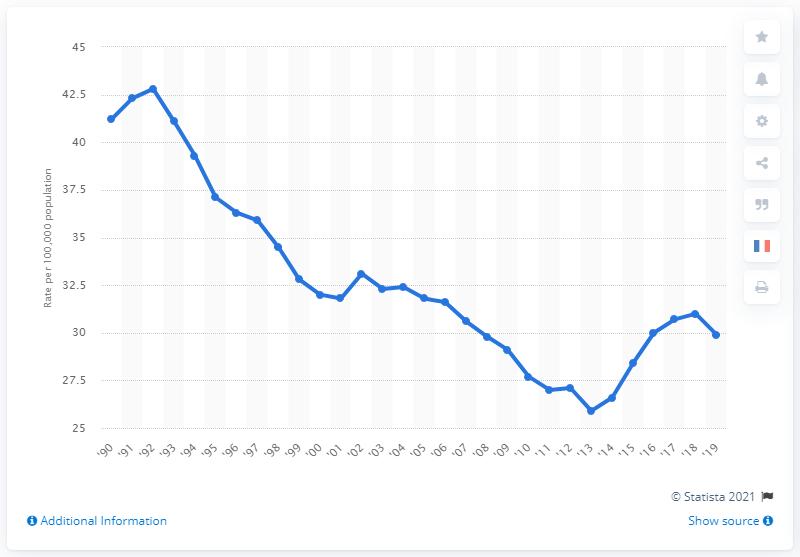Outline some significant characteristics in this image. In 1990, the rate of forcible rapes per 100,000 inhabitants was 41.2. 